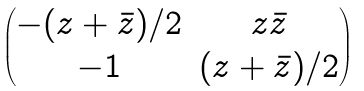Convert formula to latex. <formula><loc_0><loc_0><loc_500><loc_500>\begin{pmatrix} - ( z + \bar { z } ) / 2 & z \bar { z } \\ - 1 & ( z + \bar { z } ) / 2 \end{pmatrix}</formula> 